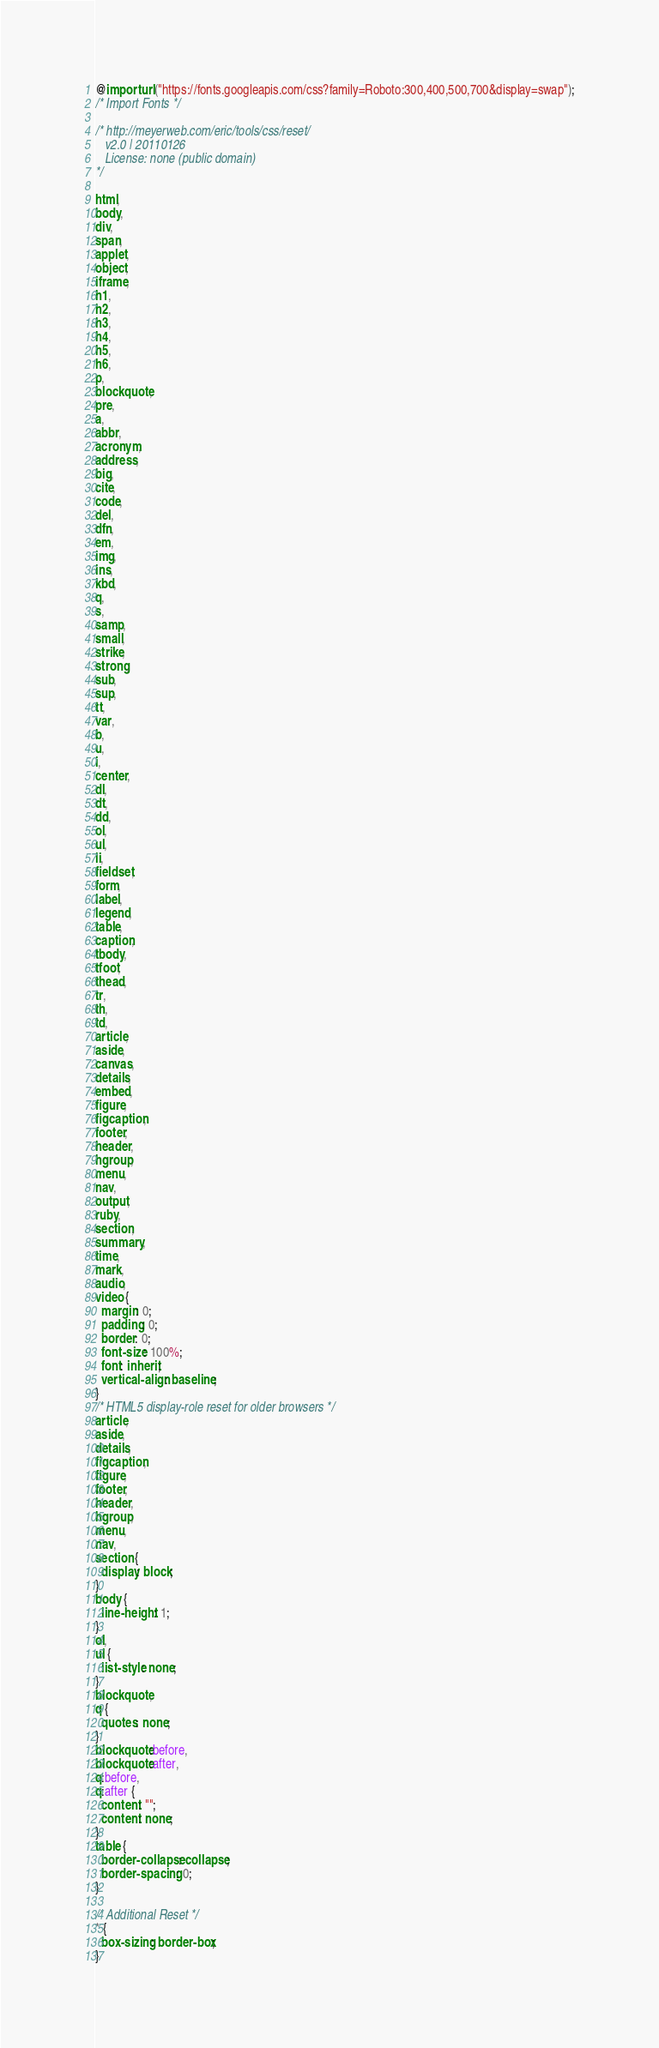Convert code to text. <code><loc_0><loc_0><loc_500><loc_500><_CSS_>@import url("https://fonts.googleapis.com/css?family=Roboto:300,400,500,700&display=swap");
/* Import Fonts */

/* http://meyerweb.com/eric/tools/css/reset/ 
   v2.0 | 20110126
   License: none (public domain)
*/

html,
body,
div,
span,
applet,
object,
iframe,
h1,
h2,
h3,
h4,
h5,
h6,
p,
blockquote,
pre,
a,
abbr,
acronym,
address,
big,
cite,
code,
del,
dfn,
em,
img,
ins,
kbd,
q,
s,
samp,
small,
strike,
strong,
sub,
sup,
tt,
var,
b,
u,
i,
center,
dl,
dt,
dd,
ol,
ul,
li,
fieldset,
form,
label,
legend,
table,
caption,
tbody,
tfoot,
thead,
tr,
th,
td,
article,
aside,
canvas,
details,
embed,
figure,
figcaption,
footer,
header,
hgroup,
menu,
nav,
output,
ruby,
section,
summary,
time,
mark,
audio,
video {
  margin: 0;
  padding: 0;
  border: 0;
  font-size: 100%;
  font: inherit;
  vertical-align: baseline;
}
/* HTML5 display-role reset for older browsers */
article,
aside,
details,
figcaption,
figure,
footer,
header,
hgroup,
menu,
nav,
section {
  display: block;
}
body {
  line-height: 1;
}
ol,
ul {
  list-style: none;
}
blockquote,
q {
  quotes: none;
}
blockquote:before,
blockquote:after,
q:before,
q:after {
  content: "";
  content: none;
}
table {
  border-collapse: collapse;
  border-spacing: 0;
}

/* Additional Reset */
* {
  box-sizing: border-box;
}
</code> 